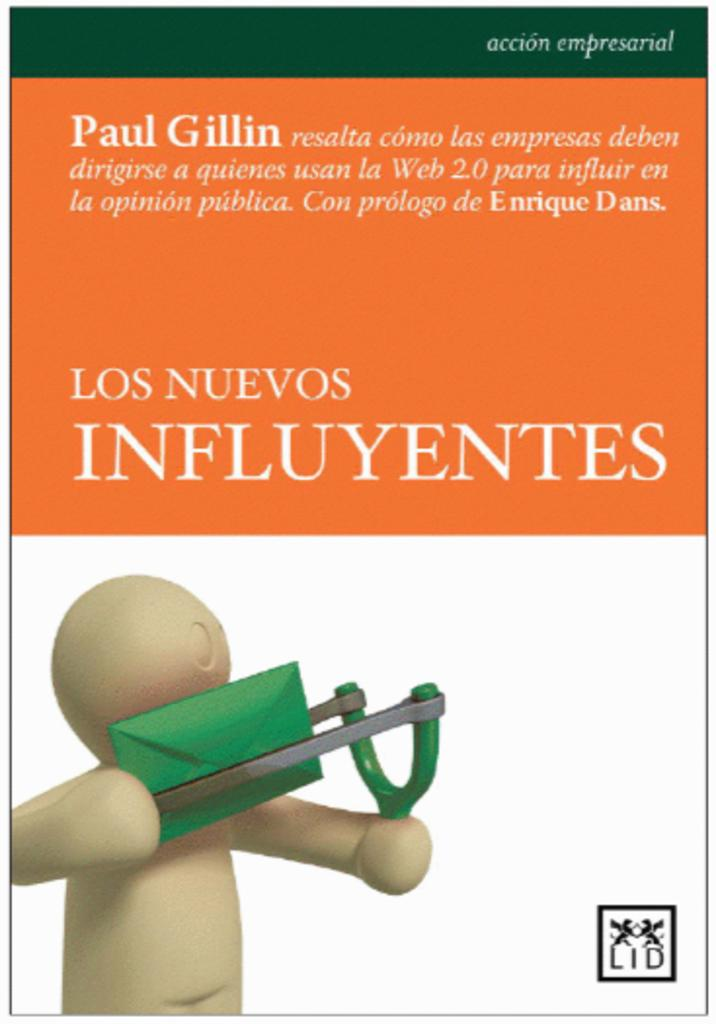What is featured on the poster in the image? There is a poster with information in the image, and it has an image of a doll. What is the doll holding in its hand? The doll is holding something in its hand, but the specific object cannot be determined from the image. How far away is the boot from the doll in the image? There is no boot present in the image, so it cannot be determined how far away it is from the doll. 